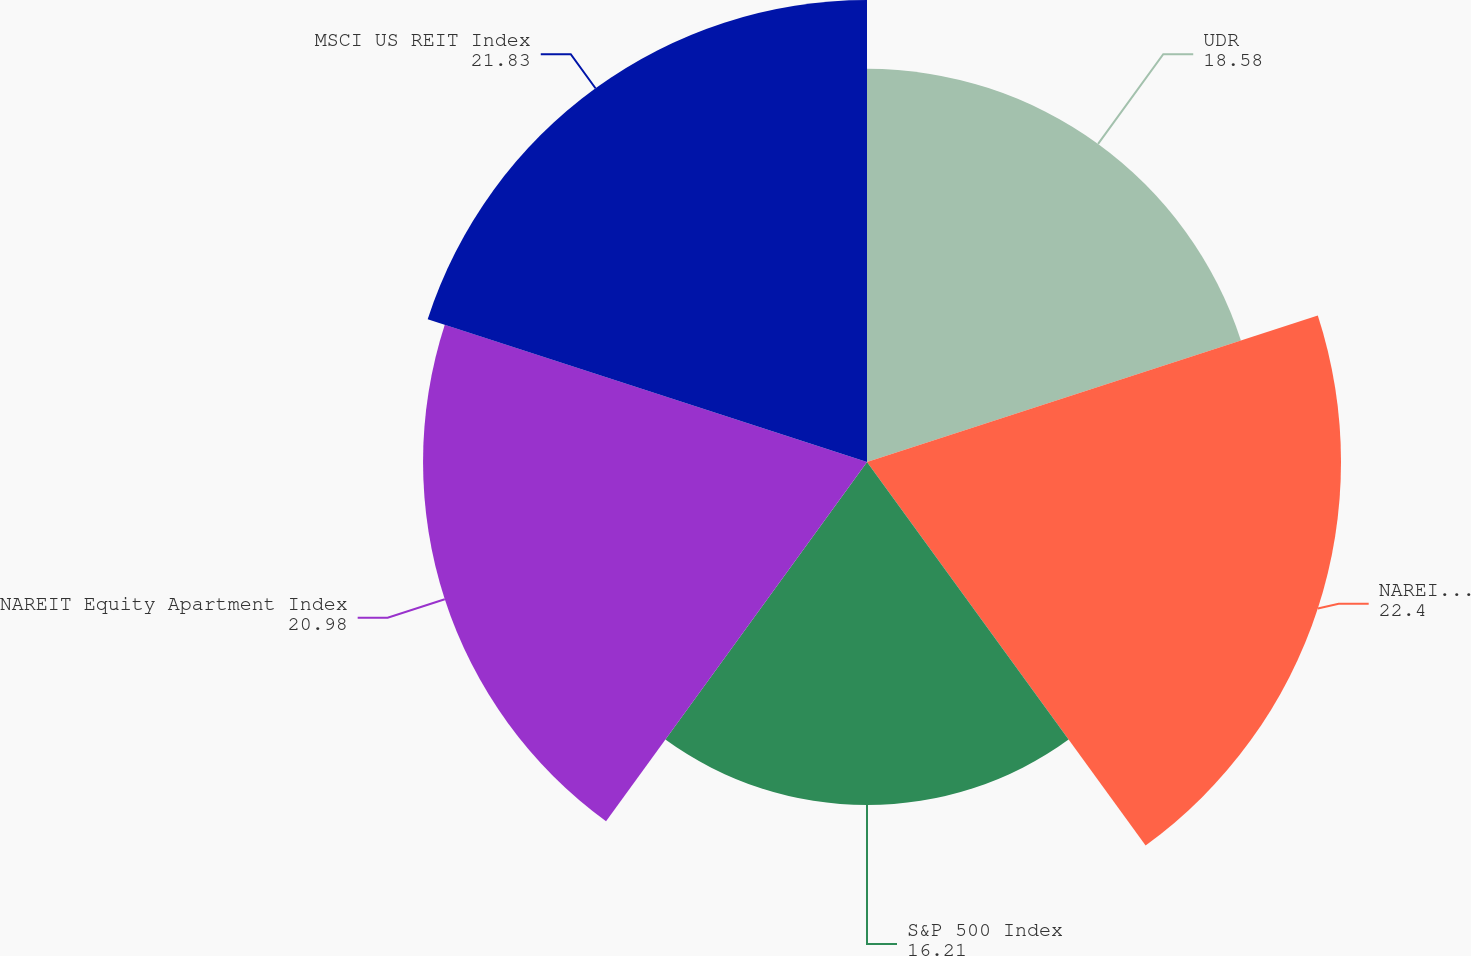Convert chart to OTSL. <chart><loc_0><loc_0><loc_500><loc_500><pie_chart><fcel>UDR<fcel>NAREIT Equity REIT Index<fcel>S&P 500 Index<fcel>NAREIT Equity Apartment Index<fcel>MSCI US REIT Index<nl><fcel>18.58%<fcel>22.4%<fcel>16.21%<fcel>20.98%<fcel>21.83%<nl></chart> 